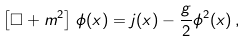<formula> <loc_0><loc_0><loc_500><loc_500>\left [ \square + m ^ { 2 } \right ] \, \phi ( x ) = j ( x ) - \frac { g } { 2 } \phi ^ { 2 } ( x ) \, ,</formula> 